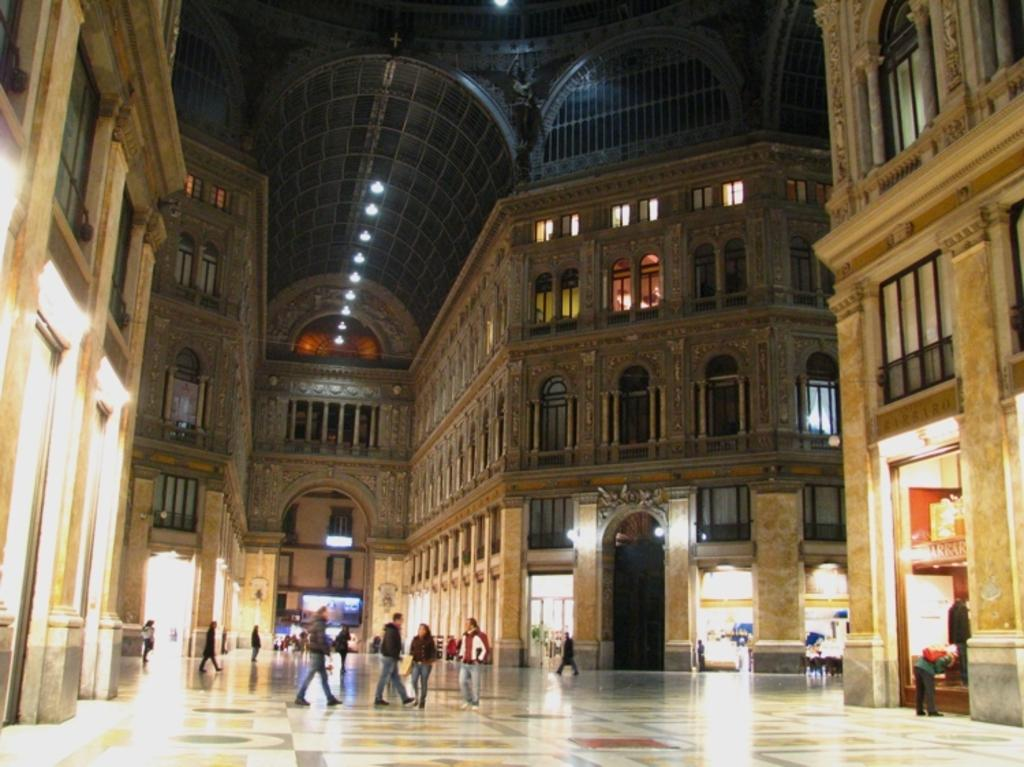What type of structures can be seen in the image? There are buildings in the image. Who or what else is present in the image? There are people in the image. Are there any sources of illumination visible in the image? Yes, there are lights in the image. What surface can be seen in the image? There is a floor in the image. What type of trousers are the pigs wearing in the image? There are no pigs or trousers present in the image. Can you describe the clouds in the image? There are no clouds present in the image. 